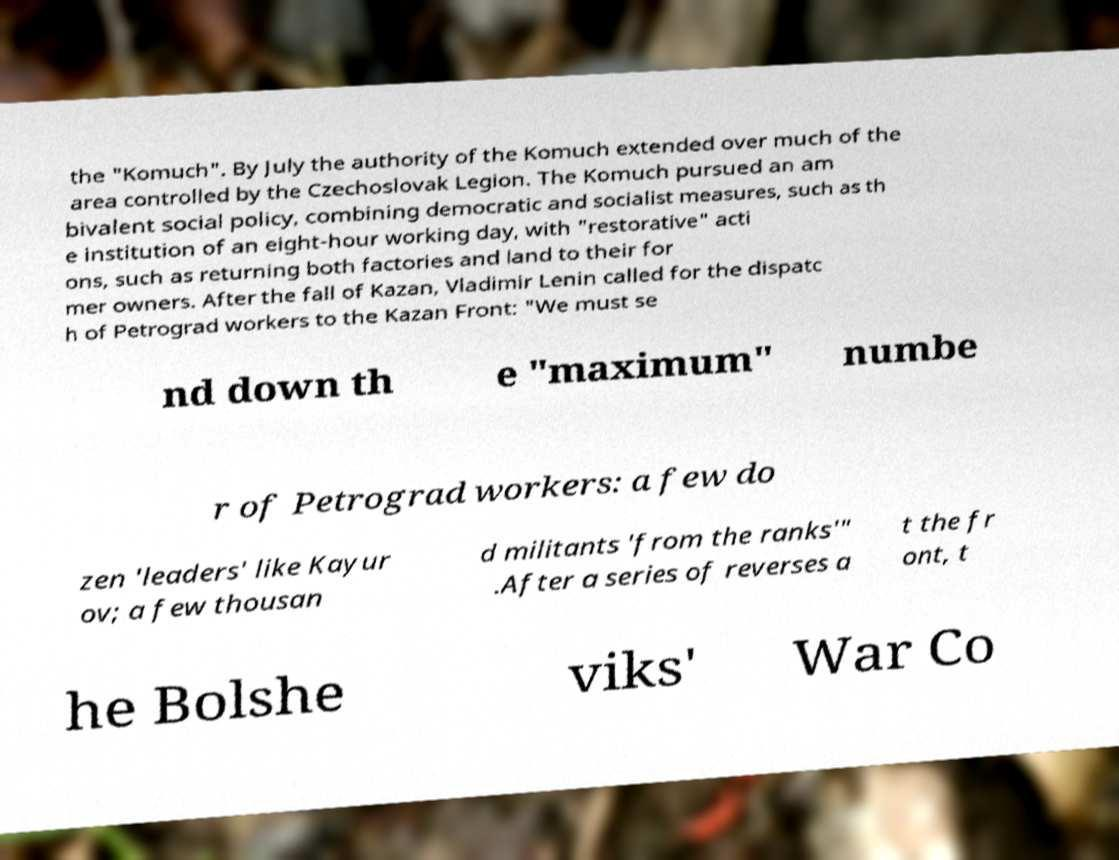Can you accurately transcribe the text from the provided image for me? the "Komuch". By July the authority of the Komuch extended over much of the area controlled by the Czechoslovak Legion. The Komuch pursued an am bivalent social policy, combining democratic and socialist measures, such as th e institution of an eight-hour working day, with "restorative" acti ons, such as returning both factories and land to their for mer owners. After the fall of Kazan, Vladimir Lenin called for the dispatc h of Petrograd workers to the Kazan Front: "We must se nd down th e "maximum" numbe r of Petrograd workers: a few do zen 'leaders' like Kayur ov; a few thousan d militants 'from the ranks'" .After a series of reverses a t the fr ont, t he Bolshe viks' War Co 